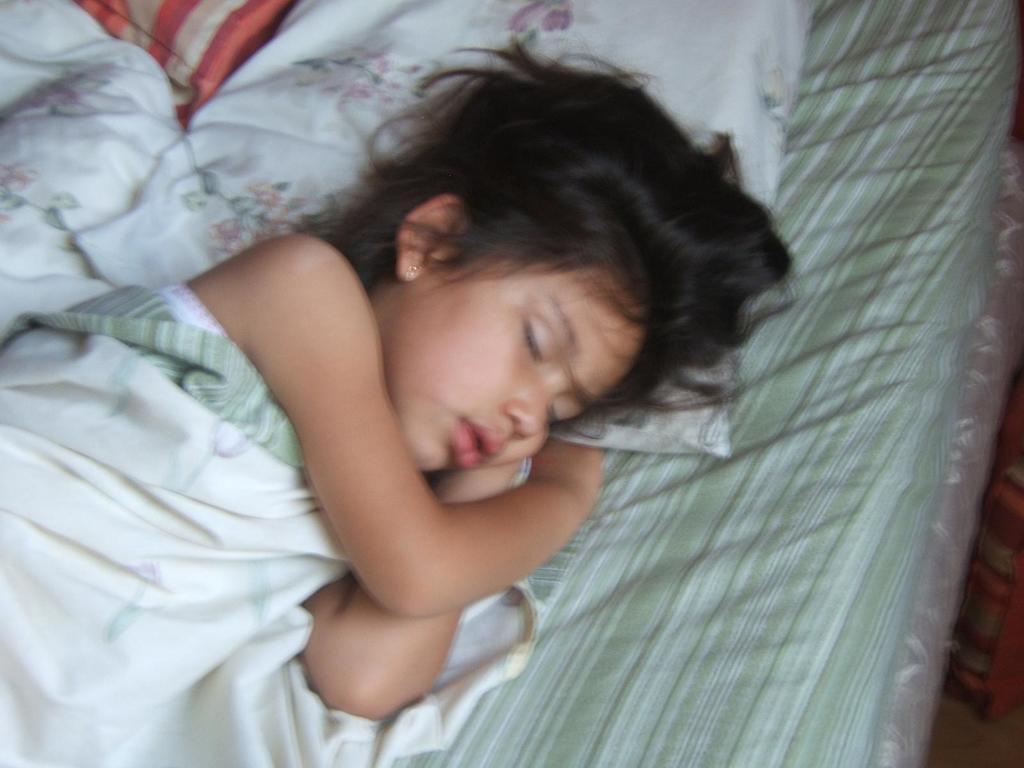Who is the main subject in the image? There is a girl in the image. What is the girl doing in the image? The girl is laying on the bed. What else can be seen in the image besides the girl? There are pillows in the image. What type of feast is the girl attending in the image? There is no feast present in the image; it only shows a girl laying on the bed with pillows. How many cows are visible in the image? There are no cows visible in the image. 